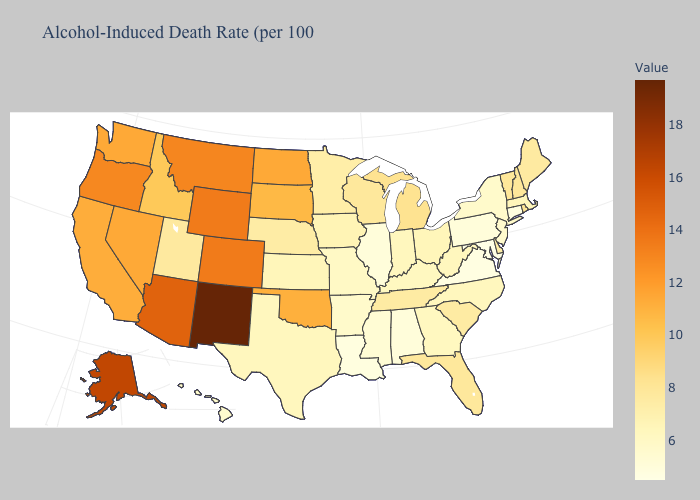Does New Mexico have the highest value in the USA?
Answer briefly. Yes. Does South Dakota have the lowest value in the MidWest?
Give a very brief answer. No. Among the states that border Idaho , does Wyoming have the highest value?
Answer briefly. Yes. Which states have the lowest value in the USA?
Give a very brief answer. Maryland. Which states hav the highest value in the West?
Short answer required. New Mexico. Which states hav the highest value in the Northeast?
Concise answer only. Rhode Island. Does Missouri have a higher value than Idaho?
Quick response, please. No. 